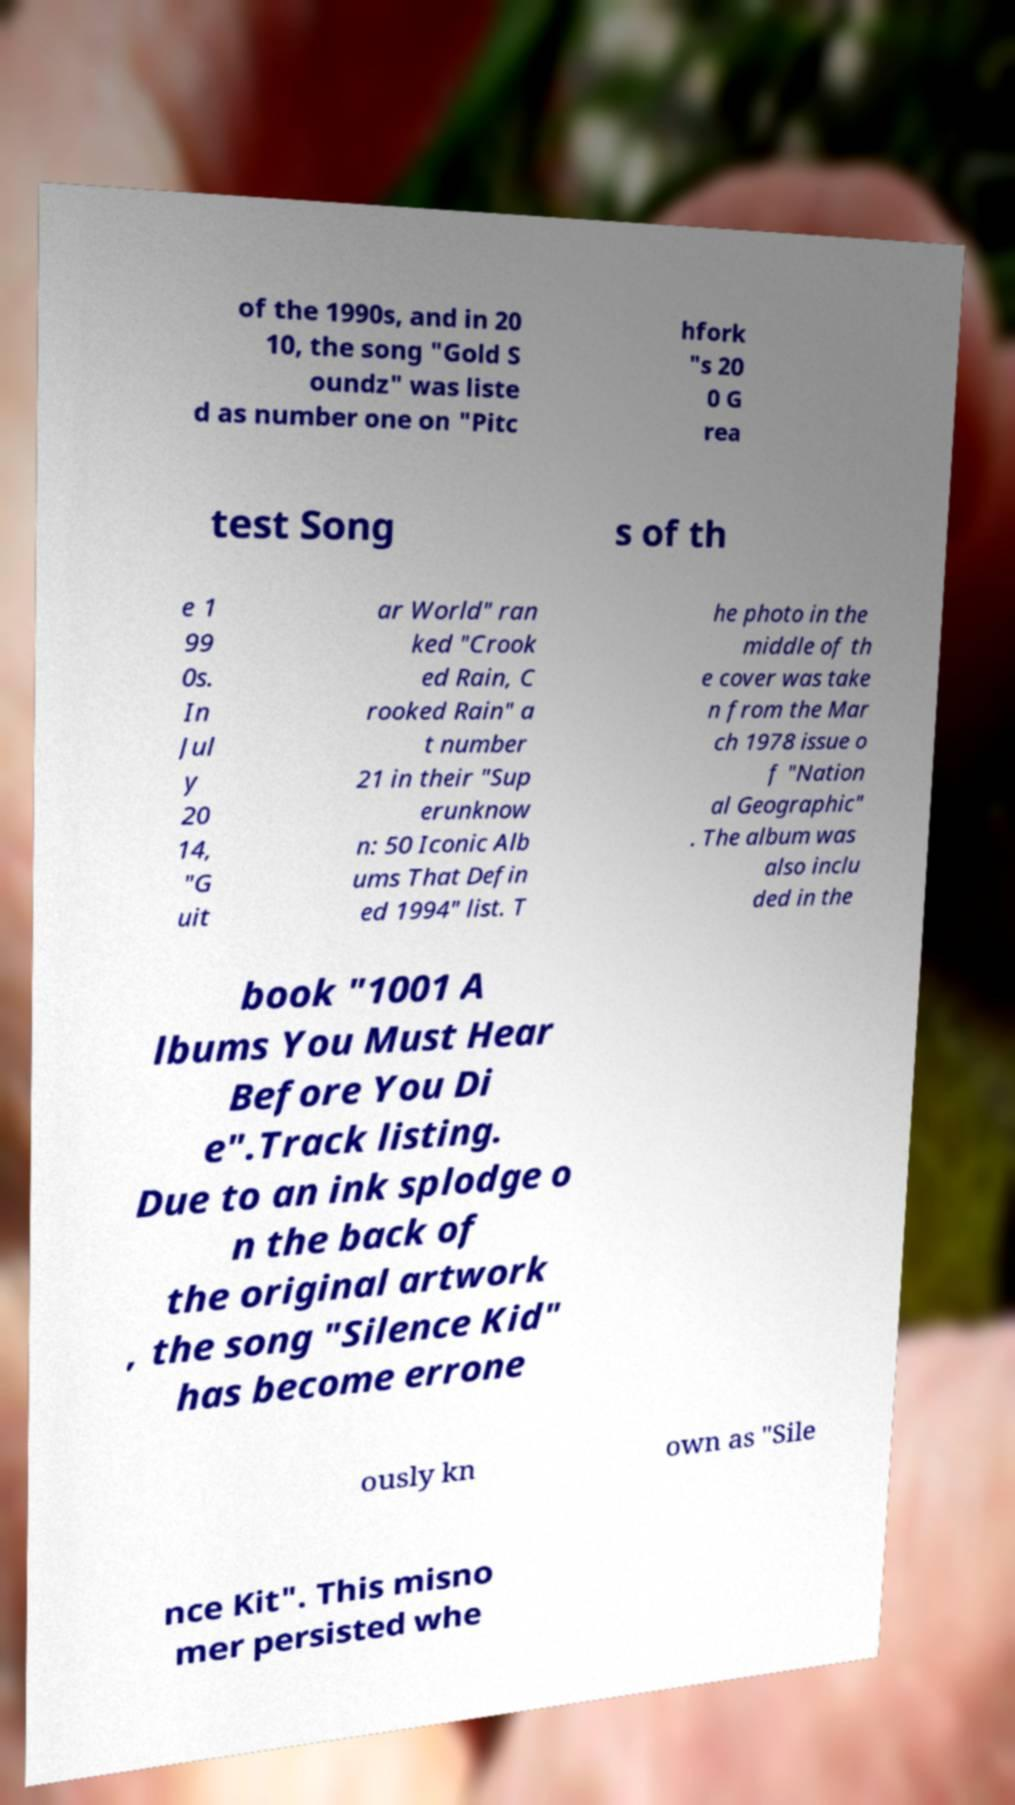I need the written content from this picture converted into text. Can you do that? of the 1990s, and in 20 10, the song "Gold S oundz" was liste d as number one on "Pitc hfork "s 20 0 G rea test Song s of th e 1 99 0s. In Jul y 20 14, "G uit ar World" ran ked "Crook ed Rain, C rooked Rain" a t number 21 in their "Sup erunknow n: 50 Iconic Alb ums That Defin ed 1994" list. T he photo in the middle of th e cover was take n from the Mar ch 1978 issue o f "Nation al Geographic" . The album was also inclu ded in the book "1001 A lbums You Must Hear Before You Di e".Track listing. Due to an ink splodge o n the back of the original artwork , the song "Silence Kid" has become errone ously kn own as "Sile nce Kit". This misno mer persisted whe 